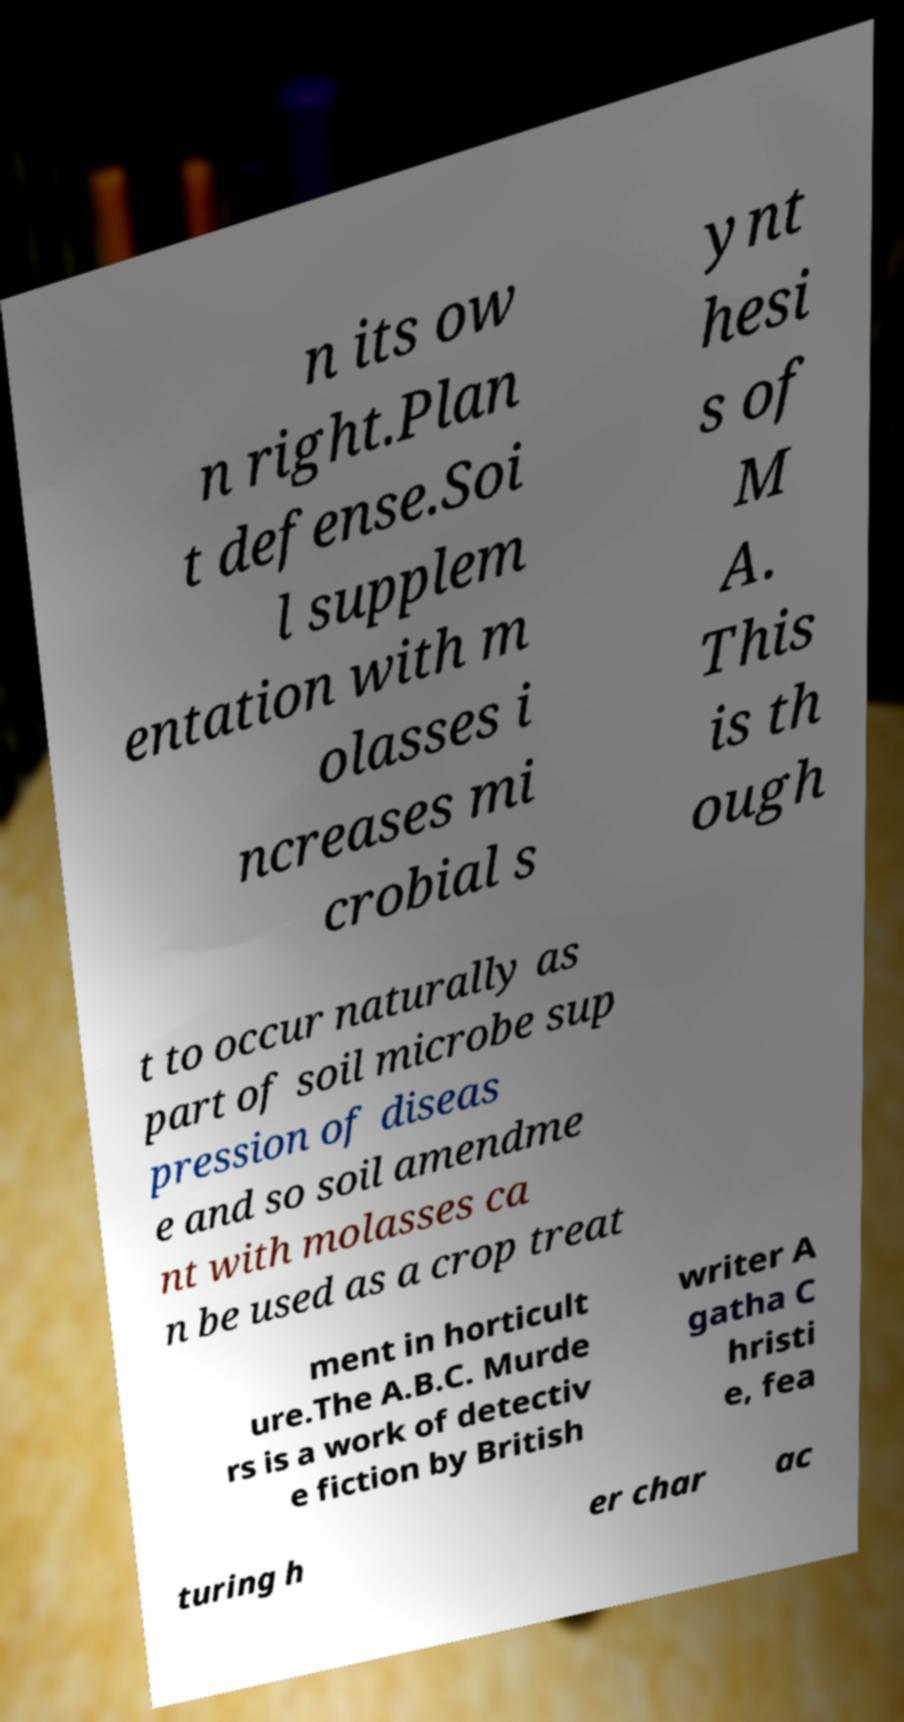What messages or text are displayed in this image? I need them in a readable, typed format. n its ow n right.Plan t defense.Soi l supplem entation with m olasses i ncreases mi crobial s ynt hesi s of M A. This is th ough t to occur naturally as part of soil microbe sup pression of diseas e and so soil amendme nt with molasses ca n be used as a crop treat ment in horticult ure.The A.B.C. Murde rs is a work of detectiv e fiction by British writer A gatha C hristi e, fea turing h er char ac 